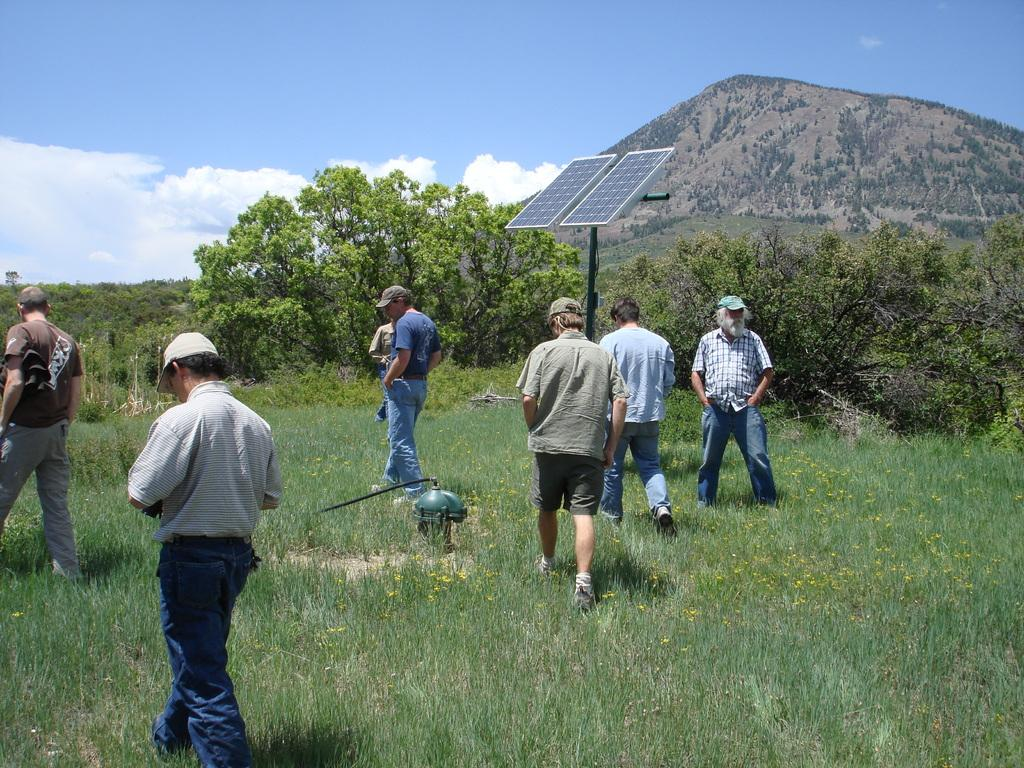What is happening in the image? There are people standing in the image. Can you describe the clothing of the people? The people are wearing different color dresses. What type of natural environment is visible in the image? There is green grass, trees, and mountains in the image. Are there any man-made structures present in the image? Yes, solar panels are present in the image. What is the color of the sky in the image? The sky is blue and white in color. What type of holiday is being celebrated in the image? There is no indication of a holiday being celebrated in the image. How many people are attending the mass in the image? There is no mass or religious gathering depicted in the image. 